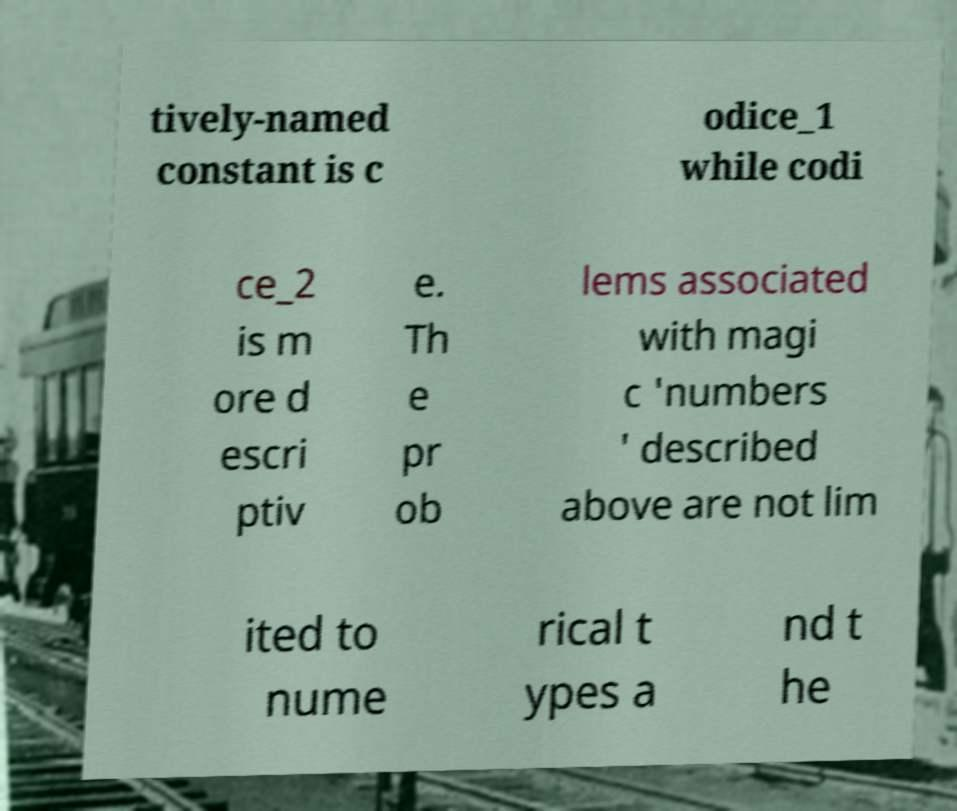For documentation purposes, I need the text within this image transcribed. Could you provide that? tively-named constant is c odice_1 while codi ce_2 is m ore d escri ptiv e. Th e pr ob lems associated with magi c 'numbers ' described above are not lim ited to nume rical t ypes a nd t he 